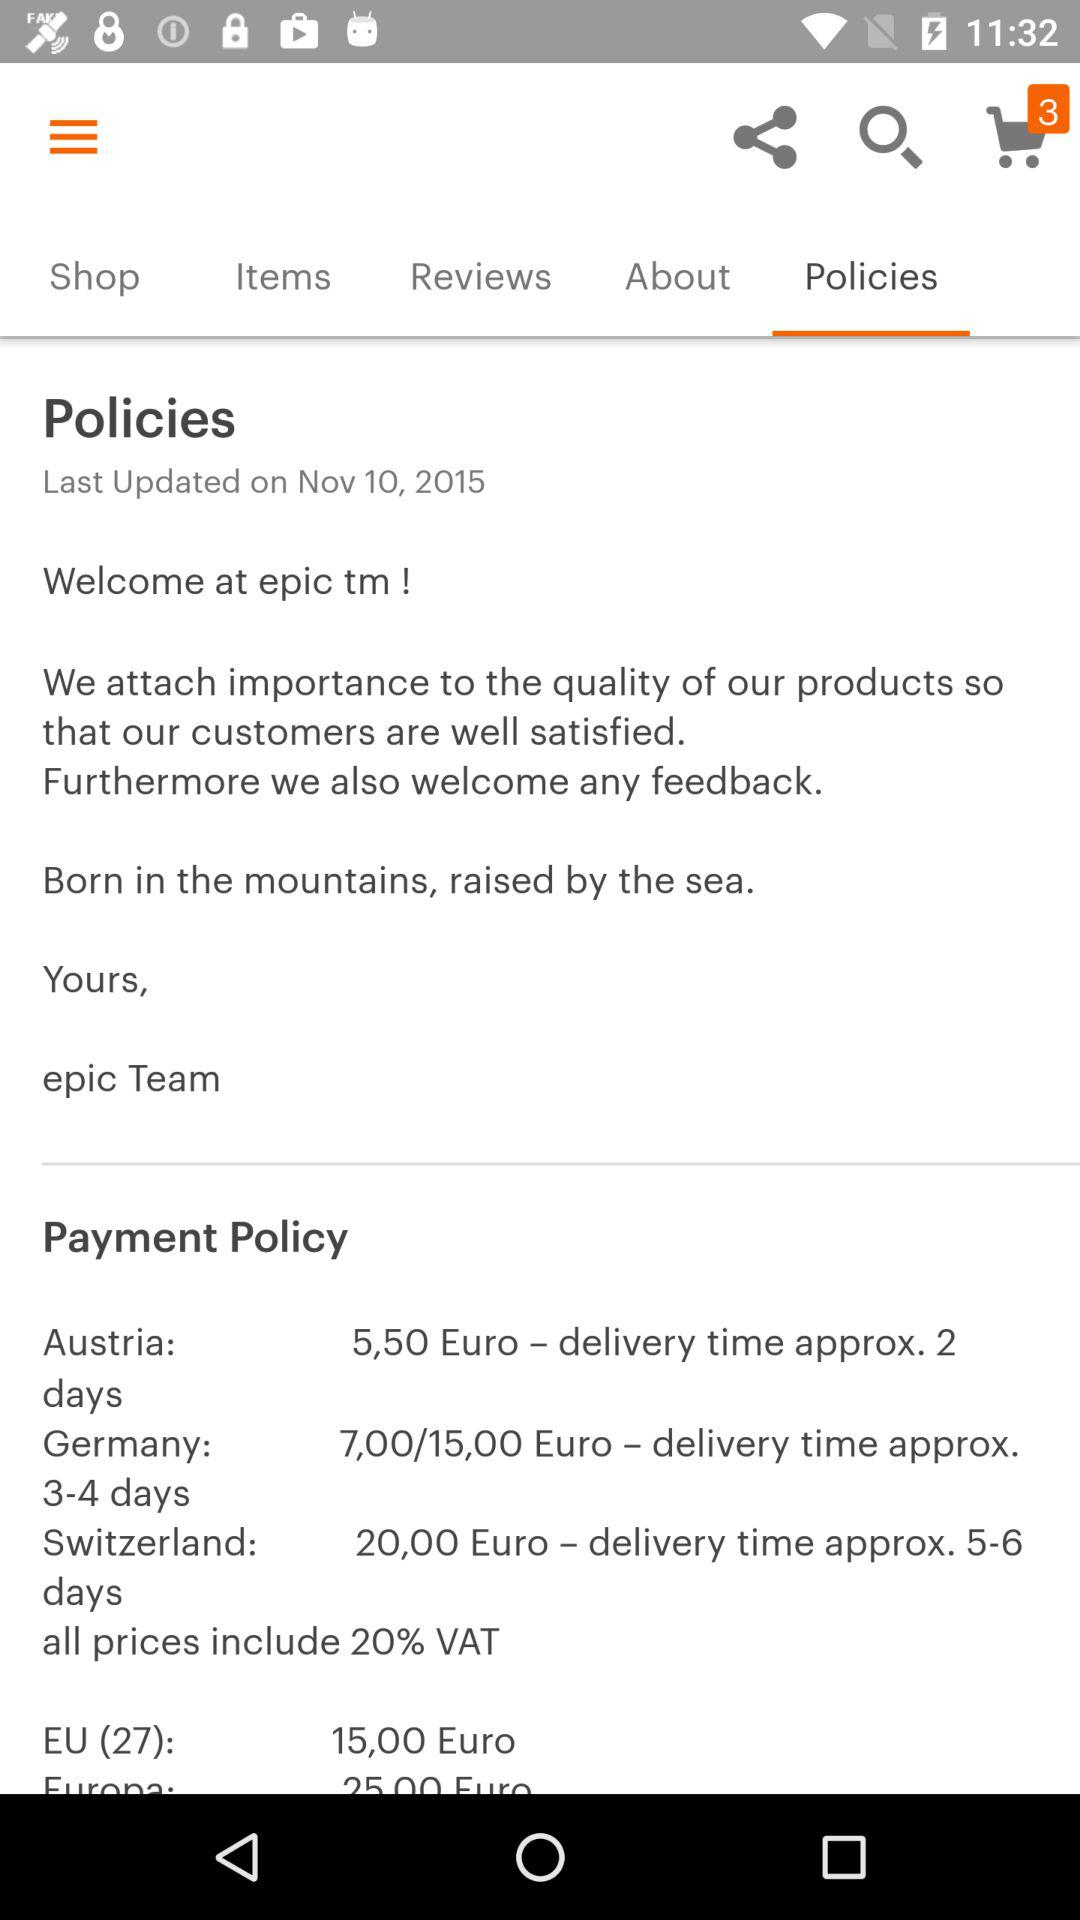What are the payment policy for Germany? The payment policy is 7,00/15,00 Euros; delivery time is approx. 3–4 days. 